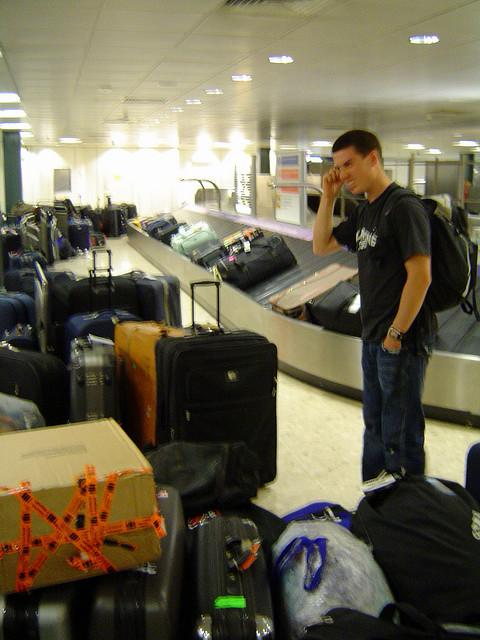What kind of reaction the person shows? Please explain your reasoning. confusion. The person shows confusion as he looks at his luggage. 